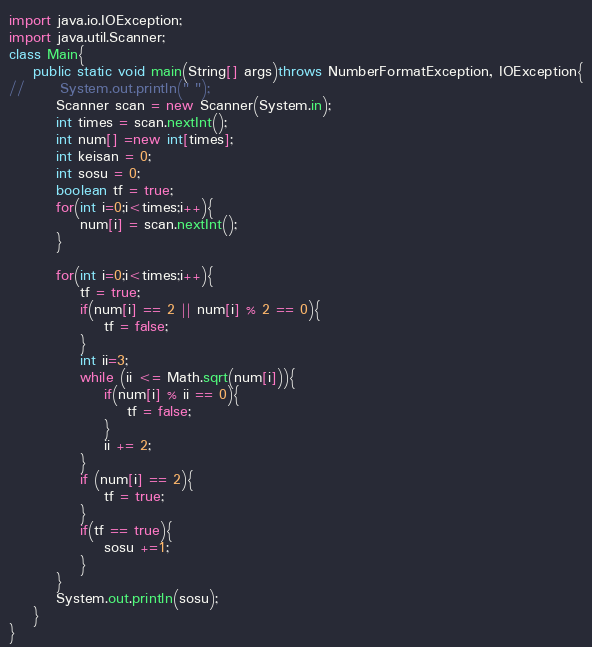<code> <loc_0><loc_0><loc_500><loc_500><_Java_>import java.io.IOException;
import java.util.Scanner;
class Main{
	public static void main(String[] args)throws NumberFormatException, IOException{
//		System.out.println(" ");
		Scanner scan = new Scanner(System.in);
		int times = scan.nextInt();
		int num[] =new int[times];
		int keisan = 0;
		int sosu = 0;
		boolean tf = true;
		for(int i=0;i<times;i++){
			num[i] = scan.nextInt();
		}

		for(int i=0;i<times;i++){
			tf = true;
			if(num[i] == 2 || num[i] % 2 == 0){
				tf = false;
			}
			int ii=3;
			while (ii <= Math.sqrt(num[i])){
				if(num[i] % ii == 0){
					tf = false;
				}
				ii += 2;
			}
			if (num[i] == 2){
				tf = true;
			}
			if(tf == true){
				sosu +=1;
			}
		}
		System.out.println(sosu);
	}
}</code> 